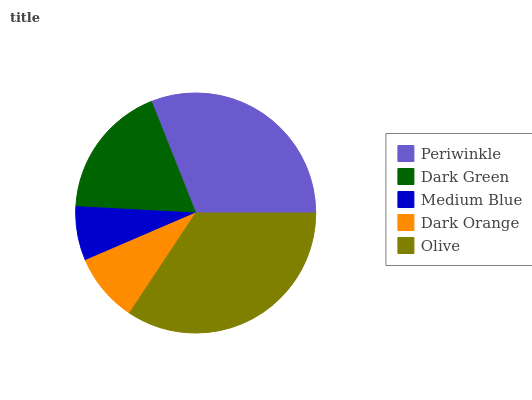Is Medium Blue the minimum?
Answer yes or no. Yes. Is Olive the maximum?
Answer yes or no. Yes. Is Dark Green the minimum?
Answer yes or no. No. Is Dark Green the maximum?
Answer yes or no. No. Is Periwinkle greater than Dark Green?
Answer yes or no. Yes. Is Dark Green less than Periwinkle?
Answer yes or no. Yes. Is Dark Green greater than Periwinkle?
Answer yes or no. No. Is Periwinkle less than Dark Green?
Answer yes or no. No. Is Dark Green the high median?
Answer yes or no. Yes. Is Dark Green the low median?
Answer yes or no. Yes. Is Periwinkle the high median?
Answer yes or no. No. Is Medium Blue the low median?
Answer yes or no. No. 